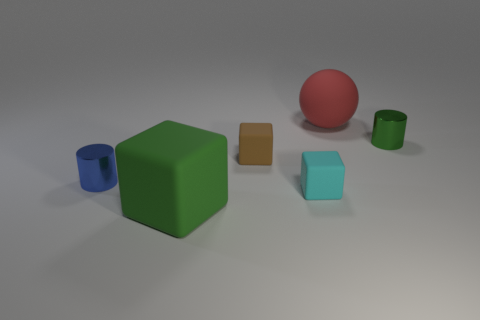Is the material of the blue thing the same as the cylinder right of the big matte sphere? Yes, it appears that both the blue item—which is a cylinder—and the smaller green cylinder to the right of the larger matte red sphere are made of the same material, likely a type of plastic, as indicated by their similar sheens and light reflections. 